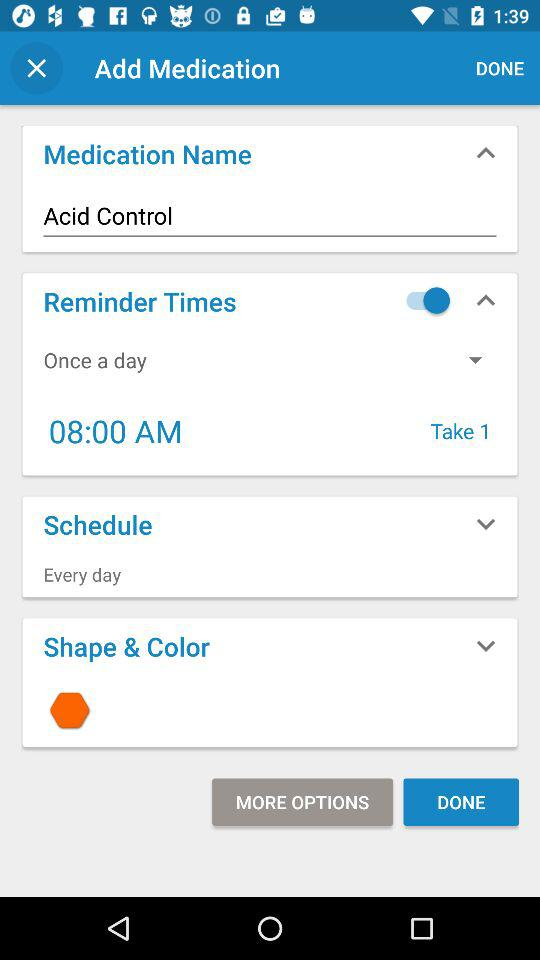How many times medicine should be taken daily? You should take medicine once a day. 